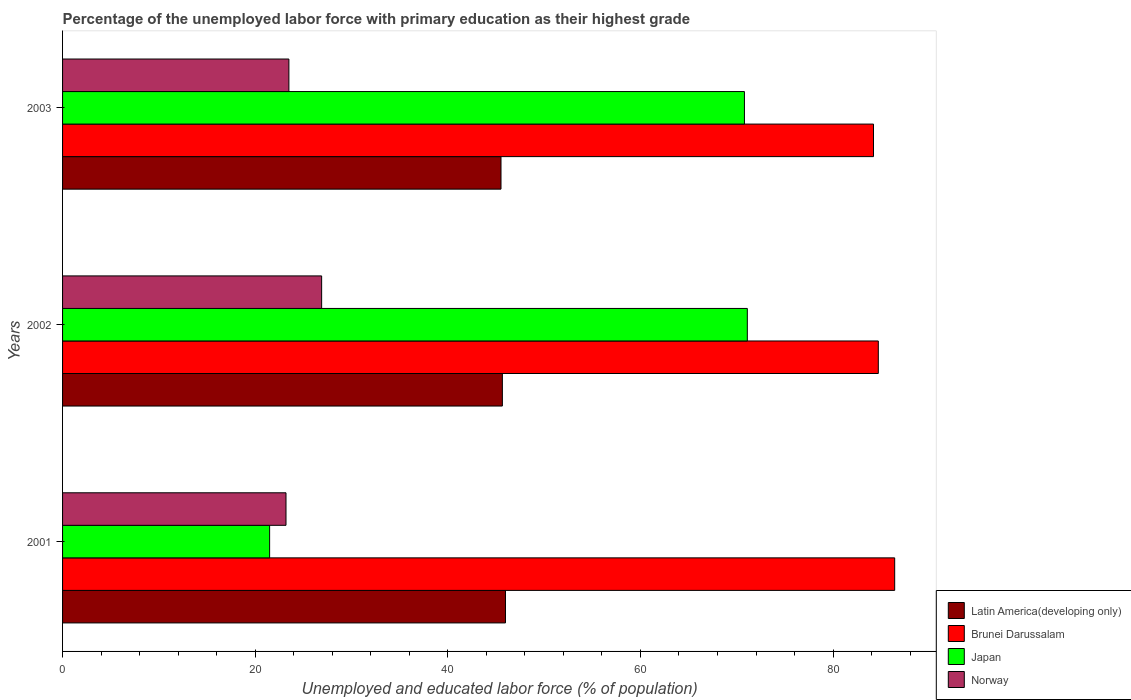How many different coloured bars are there?
Your answer should be compact. 4. Are the number of bars per tick equal to the number of legend labels?
Your answer should be very brief. Yes. Are the number of bars on each tick of the Y-axis equal?
Keep it short and to the point. Yes. How many bars are there on the 2nd tick from the top?
Your response must be concise. 4. How many bars are there on the 1st tick from the bottom?
Provide a succinct answer. 4. In how many cases, is the number of bars for a given year not equal to the number of legend labels?
Provide a short and direct response. 0. What is the percentage of the unemployed labor force with primary education in Brunei Darussalam in 2002?
Offer a very short reply. 84.7. Across all years, what is the maximum percentage of the unemployed labor force with primary education in Norway?
Give a very brief answer. 26.9. Across all years, what is the minimum percentage of the unemployed labor force with primary education in Japan?
Your response must be concise. 21.5. In which year was the percentage of the unemployed labor force with primary education in Brunei Darussalam maximum?
Your answer should be very brief. 2001. In which year was the percentage of the unemployed labor force with primary education in Japan minimum?
Keep it short and to the point. 2001. What is the total percentage of the unemployed labor force with primary education in Japan in the graph?
Give a very brief answer. 163.4. What is the difference between the percentage of the unemployed labor force with primary education in Japan in 2002 and that in 2003?
Give a very brief answer. 0.3. What is the difference between the percentage of the unemployed labor force with primary education in Norway in 2001 and the percentage of the unemployed labor force with primary education in Latin America(developing only) in 2002?
Offer a very short reply. -22.47. What is the average percentage of the unemployed labor force with primary education in Norway per year?
Offer a very short reply. 24.53. In the year 2002, what is the difference between the percentage of the unemployed labor force with primary education in Latin America(developing only) and percentage of the unemployed labor force with primary education in Norway?
Provide a short and direct response. 18.77. What is the ratio of the percentage of the unemployed labor force with primary education in Latin America(developing only) in 2002 to that in 2003?
Your response must be concise. 1. Is the percentage of the unemployed labor force with primary education in Norway in 2002 less than that in 2003?
Ensure brevity in your answer.  No. Is the difference between the percentage of the unemployed labor force with primary education in Latin America(developing only) in 2002 and 2003 greater than the difference between the percentage of the unemployed labor force with primary education in Norway in 2002 and 2003?
Ensure brevity in your answer.  No. What is the difference between the highest and the second highest percentage of the unemployed labor force with primary education in Norway?
Provide a short and direct response. 3.4. What is the difference between the highest and the lowest percentage of the unemployed labor force with primary education in Norway?
Offer a terse response. 3.7. In how many years, is the percentage of the unemployed labor force with primary education in Japan greater than the average percentage of the unemployed labor force with primary education in Japan taken over all years?
Provide a short and direct response. 2. What does the 4th bar from the top in 2003 represents?
Your answer should be very brief. Latin America(developing only). What does the 2nd bar from the bottom in 2001 represents?
Keep it short and to the point. Brunei Darussalam. Are all the bars in the graph horizontal?
Your response must be concise. Yes. Does the graph contain any zero values?
Give a very brief answer. No. What is the title of the graph?
Offer a terse response. Percentage of the unemployed labor force with primary education as their highest grade. Does "Peru" appear as one of the legend labels in the graph?
Your answer should be very brief. No. What is the label or title of the X-axis?
Ensure brevity in your answer.  Unemployed and educated labor force (% of population). What is the Unemployed and educated labor force (% of population) in Latin America(developing only) in 2001?
Provide a short and direct response. 45.99. What is the Unemployed and educated labor force (% of population) of Brunei Darussalam in 2001?
Keep it short and to the point. 86.4. What is the Unemployed and educated labor force (% of population) in Japan in 2001?
Provide a short and direct response. 21.5. What is the Unemployed and educated labor force (% of population) of Norway in 2001?
Your response must be concise. 23.2. What is the Unemployed and educated labor force (% of population) in Latin America(developing only) in 2002?
Ensure brevity in your answer.  45.67. What is the Unemployed and educated labor force (% of population) of Brunei Darussalam in 2002?
Make the answer very short. 84.7. What is the Unemployed and educated labor force (% of population) in Japan in 2002?
Your answer should be very brief. 71.1. What is the Unemployed and educated labor force (% of population) in Norway in 2002?
Ensure brevity in your answer.  26.9. What is the Unemployed and educated labor force (% of population) of Latin America(developing only) in 2003?
Provide a succinct answer. 45.52. What is the Unemployed and educated labor force (% of population) in Brunei Darussalam in 2003?
Provide a succinct answer. 84.2. What is the Unemployed and educated labor force (% of population) of Japan in 2003?
Keep it short and to the point. 70.8. Across all years, what is the maximum Unemployed and educated labor force (% of population) in Latin America(developing only)?
Offer a terse response. 45.99. Across all years, what is the maximum Unemployed and educated labor force (% of population) of Brunei Darussalam?
Keep it short and to the point. 86.4. Across all years, what is the maximum Unemployed and educated labor force (% of population) in Japan?
Keep it short and to the point. 71.1. Across all years, what is the maximum Unemployed and educated labor force (% of population) of Norway?
Make the answer very short. 26.9. Across all years, what is the minimum Unemployed and educated labor force (% of population) in Latin America(developing only)?
Your answer should be very brief. 45.52. Across all years, what is the minimum Unemployed and educated labor force (% of population) of Brunei Darussalam?
Your response must be concise. 84.2. Across all years, what is the minimum Unemployed and educated labor force (% of population) in Japan?
Offer a terse response. 21.5. Across all years, what is the minimum Unemployed and educated labor force (% of population) of Norway?
Your response must be concise. 23.2. What is the total Unemployed and educated labor force (% of population) in Latin America(developing only) in the graph?
Provide a succinct answer. 137.18. What is the total Unemployed and educated labor force (% of population) of Brunei Darussalam in the graph?
Make the answer very short. 255.3. What is the total Unemployed and educated labor force (% of population) in Japan in the graph?
Offer a very short reply. 163.4. What is the total Unemployed and educated labor force (% of population) of Norway in the graph?
Your answer should be compact. 73.6. What is the difference between the Unemployed and educated labor force (% of population) of Latin America(developing only) in 2001 and that in 2002?
Provide a short and direct response. 0.32. What is the difference between the Unemployed and educated labor force (% of population) of Brunei Darussalam in 2001 and that in 2002?
Provide a short and direct response. 1.7. What is the difference between the Unemployed and educated labor force (% of population) in Japan in 2001 and that in 2002?
Give a very brief answer. -49.6. What is the difference between the Unemployed and educated labor force (% of population) in Norway in 2001 and that in 2002?
Provide a short and direct response. -3.7. What is the difference between the Unemployed and educated labor force (% of population) in Latin America(developing only) in 2001 and that in 2003?
Provide a succinct answer. 0.47. What is the difference between the Unemployed and educated labor force (% of population) in Japan in 2001 and that in 2003?
Your response must be concise. -49.3. What is the difference between the Unemployed and educated labor force (% of population) of Latin America(developing only) in 2002 and that in 2003?
Your answer should be compact. 0.14. What is the difference between the Unemployed and educated labor force (% of population) of Brunei Darussalam in 2002 and that in 2003?
Your response must be concise. 0.5. What is the difference between the Unemployed and educated labor force (% of population) in Norway in 2002 and that in 2003?
Provide a succinct answer. 3.4. What is the difference between the Unemployed and educated labor force (% of population) in Latin America(developing only) in 2001 and the Unemployed and educated labor force (% of population) in Brunei Darussalam in 2002?
Give a very brief answer. -38.71. What is the difference between the Unemployed and educated labor force (% of population) of Latin America(developing only) in 2001 and the Unemployed and educated labor force (% of population) of Japan in 2002?
Offer a very short reply. -25.11. What is the difference between the Unemployed and educated labor force (% of population) in Latin America(developing only) in 2001 and the Unemployed and educated labor force (% of population) in Norway in 2002?
Make the answer very short. 19.09. What is the difference between the Unemployed and educated labor force (% of population) in Brunei Darussalam in 2001 and the Unemployed and educated labor force (% of population) in Japan in 2002?
Your response must be concise. 15.3. What is the difference between the Unemployed and educated labor force (% of population) in Brunei Darussalam in 2001 and the Unemployed and educated labor force (% of population) in Norway in 2002?
Ensure brevity in your answer.  59.5. What is the difference between the Unemployed and educated labor force (% of population) of Latin America(developing only) in 2001 and the Unemployed and educated labor force (% of population) of Brunei Darussalam in 2003?
Offer a very short reply. -38.21. What is the difference between the Unemployed and educated labor force (% of population) in Latin America(developing only) in 2001 and the Unemployed and educated labor force (% of population) in Japan in 2003?
Provide a succinct answer. -24.81. What is the difference between the Unemployed and educated labor force (% of population) in Latin America(developing only) in 2001 and the Unemployed and educated labor force (% of population) in Norway in 2003?
Your answer should be compact. 22.49. What is the difference between the Unemployed and educated labor force (% of population) of Brunei Darussalam in 2001 and the Unemployed and educated labor force (% of population) of Norway in 2003?
Provide a succinct answer. 62.9. What is the difference between the Unemployed and educated labor force (% of population) of Latin America(developing only) in 2002 and the Unemployed and educated labor force (% of population) of Brunei Darussalam in 2003?
Your answer should be very brief. -38.53. What is the difference between the Unemployed and educated labor force (% of population) of Latin America(developing only) in 2002 and the Unemployed and educated labor force (% of population) of Japan in 2003?
Ensure brevity in your answer.  -25.13. What is the difference between the Unemployed and educated labor force (% of population) of Latin America(developing only) in 2002 and the Unemployed and educated labor force (% of population) of Norway in 2003?
Provide a short and direct response. 22.17. What is the difference between the Unemployed and educated labor force (% of population) of Brunei Darussalam in 2002 and the Unemployed and educated labor force (% of population) of Japan in 2003?
Make the answer very short. 13.9. What is the difference between the Unemployed and educated labor force (% of population) in Brunei Darussalam in 2002 and the Unemployed and educated labor force (% of population) in Norway in 2003?
Provide a short and direct response. 61.2. What is the difference between the Unemployed and educated labor force (% of population) in Japan in 2002 and the Unemployed and educated labor force (% of population) in Norway in 2003?
Keep it short and to the point. 47.6. What is the average Unemployed and educated labor force (% of population) in Latin America(developing only) per year?
Ensure brevity in your answer.  45.73. What is the average Unemployed and educated labor force (% of population) in Brunei Darussalam per year?
Provide a short and direct response. 85.1. What is the average Unemployed and educated labor force (% of population) of Japan per year?
Provide a short and direct response. 54.47. What is the average Unemployed and educated labor force (% of population) of Norway per year?
Your answer should be very brief. 24.53. In the year 2001, what is the difference between the Unemployed and educated labor force (% of population) in Latin America(developing only) and Unemployed and educated labor force (% of population) in Brunei Darussalam?
Offer a terse response. -40.41. In the year 2001, what is the difference between the Unemployed and educated labor force (% of population) in Latin America(developing only) and Unemployed and educated labor force (% of population) in Japan?
Your answer should be compact. 24.49. In the year 2001, what is the difference between the Unemployed and educated labor force (% of population) of Latin America(developing only) and Unemployed and educated labor force (% of population) of Norway?
Ensure brevity in your answer.  22.79. In the year 2001, what is the difference between the Unemployed and educated labor force (% of population) in Brunei Darussalam and Unemployed and educated labor force (% of population) in Japan?
Give a very brief answer. 64.9. In the year 2001, what is the difference between the Unemployed and educated labor force (% of population) in Brunei Darussalam and Unemployed and educated labor force (% of population) in Norway?
Provide a short and direct response. 63.2. In the year 2001, what is the difference between the Unemployed and educated labor force (% of population) of Japan and Unemployed and educated labor force (% of population) of Norway?
Your answer should be very brief. -1.7. In the year 2002, what is the difference between the Unemployed and educated labor force (% of population) of Latin America(developing only) and Unemployed and educated labor force (% of population) of Brunei Darussalam?
Keep it short and to the point. -39.03. In the year 2002, what is the difference between the Unemployed and educated labor force (% of population) of Latin America(developing only) and Unemployed and educated labor force (% of population) of Japan?
Provide a short and direct response. -25.43. In the year 2002, what is the difference between the Unemployed and educated labor force (% of population) of Latin America(developing only) and Unemployed and educated labor force (% of population) of Norway?
Your response must be concise. 18.77. In the year 2002, what is the difference between the Unemployed and educated labor force (% of population) of Brunei Darussalam and Unemployed and educated labor force (% of population) of Norway?
Keep it short and to the point. 57.8. In the year 2002, what is the difference between the Unemployed and educated labor force (% of population) in Japan and Unemployed and educated labor force (% of population) in Norway?
Offer a very short reply. 44.2. In the year 2003, what is the difference between the Unemployed and educated labor force (% of population) of Latin America(developing only) and Unemployed and educated labor force (% of population) of Brunei Darussalam?
Ensure brevity in your answer.  -38.68. In the year 2003, what is the difference between the Unemployed and educated labor force (% of population) in Latin America(developing only) and Unemployed and educated labor force (% of population) in Japan?
Provide a succinct answer. -25.28. In the year 2003, what is the difference between the Unemployed and educated labor force (% of population) of Latin America(developing only) and Unemployed and educated labor force (% of population) of Norway?
Make the answer very short. 22.02. In the year 2003, what is the difference between the Unemployed and educated labor force (% of population) of Brunei Darussalam and Unemployed and educated labor force (% of population) of Japan?
Your answer should be very brief. 13.4. In the year 2003, what is the difference between the Unemployed and educated labor force (% of population) in Brunei Darussalam and Unemployed and educated labor force (% of population) in Norway?
Offer a terse response. 60.7. In the year 2003, what is the difference between the Unemployed and educated labor force (% of population) in Japan and Unemployed and educated labor force (% of population) in Norway?
Keep it short and to the point. 47.3. What is the ratio of the Unemployed and educated labor force (% of population) of Latin America(developing only) in 2001 to that in 2002?
Your response must be concise. 1.01. What is the ratio of the Unemployed and educated labor force (% of population) of Brunei Darussalam in 2001 to that in 2002?
Your answer should be compact. 1.02. What is the ratio of the Unemployed and educated labor force (% of population) in Japan in 2001 to that in 2002?
Keep it short and to the point. 0.3. What is the ratio of the Unemployed and educated labor force (% of population) of Norway in 2001 to that in 2002?
Your answer should be compact. 0.86. What is the ratio of the Unemployed and educated labor force (% of population) of Latin America(developing only) in 2001 to that in 2003?
Provide a short and direct response. 1.01. What is the ratio of the Unemployed and educated labor force (% of population) in Brunei Darussalam in 2001 to that in 2003?
Offer a terse response. 1.03. What is the ratio of the Unemployed and educated labor force (% of population) of Japan in 2001 to that in 2003?
Your answer should be compact. 0.3. What is the ratio of the Unemployed and educated labor force (% of population) in Norway in 2001 to that in 2003?
Give a very brief answer. 0.99. What is the ratio of the Unemployed and educated labor force (% of population) of Brunei Darussalam in 2002 to that in 2003?
Provide a succinct answer. 1.01. What is the ratio of the Unemployed and educated labor force (% of population) of Norway in 2002 to that in 2003?
Provide a short and direct response. 1.14. What is the difference between the highest and the second highest Unemployed and educated labor force (% of population) of Latin America(developing only)?
Ensure brevity in your answer.  0.32. What is the difference between the highest and the second highest Unemployed and educated labor force (% of population) in Brunei Darussalam?
Offer a terse response. 1.7. What is the difference between the highest and the second highest Unemployed and educated labor force (% of population) of Japan?
Offer a very short reply. 0.3. What is the difference between the highest and the second highest Unemployed and educated labor force (% of population) in Norway?
Make the answer very short. 3.4. What is the difference between the highest and the lowest Unemployed and educated labor force (% of population) in Latin America(developing only)?
Make the answer very short. 0.47. What is the difference between the highest and the lowest Unemployed and educated labor force (% of population) of Brunei Darussalam?
Give a very brief answer. 2.2. What is the difference between the highest and the lowest Unemployed and educated labor force (% of population) in Japan?
Your answer should be compact. 49.6. What is the difference between the highest and the lowest Unemployed and educated labor force (% of population) in Norway?
Keep it short and to the point. 3.7. 